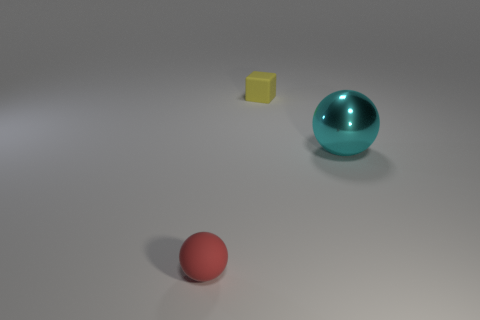Is there any other thing that is made of the same material as the big cyan thing?
Give a very brief answer. No. Are there any matte cubes left of the small thing to the left of the rubber thing behind the cyan sphere?
Your answer should be compact. No. What is the shape of the red object that is made of the same material as the tiny yellow block?
Ensure brevity in your answer.  Sphere. Are there more yellow cubes than big gray cubes?
Offer a very short reply. Yes. Do the metal object and the matte thing on the right side of the red thing have the same shape?
Ensure brevity in your answer.  No. What material is the tiny yellow block?
Your answer should be very brief. Rubber. There is a object behind the large ball in front of the small rubber thing that is to the right of the small red matte object; what color is it?
Offer a terse response. Yellow. What is the material of the other thing that is the same shape as the red rubber object?
Provide a succinct answer. Metal. How many other green metal blocks are the same size as the cube?
Offer a terse response. 0. How many small yellow blocks are there?
Provide a short and direct response. 1. 